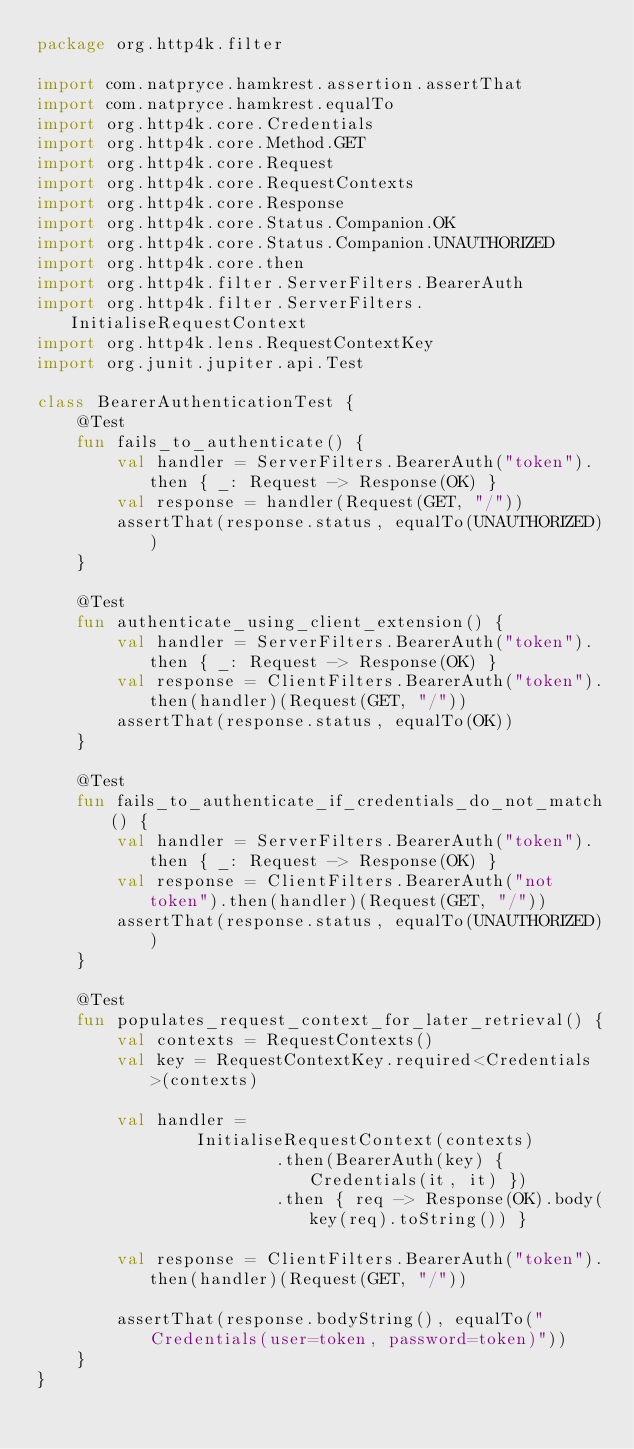Convert code to text. <code><loc_0><loc_0><loc_500><loc_500><_Kotlin_>package org.http4k.filter

import com.natpryce.hamkrest.assertion.assertThat
import com.natpryce.hamkrest.equalTo
import org.http4k.core.Credentials
import org.http4k.core.Method.GET
import org.http4k.core.Request
import org.http4k.core.RequestContexts
import org.http4k.core.Response
import org.http4k.core.Status.Companion.OK
import org.http4k.core.Status.Companion.UNAUTHORIZED
import org.http4k.core.then
import org.http4k.filter.ServerFilters.BearerAuth
import org.http4k.filter.ServerFilters.InitialiseRequestContext
import org.http4k.lens.RequestContextKey
import org.junit.jupiter.api.Test

class BearerAuthenticationTest {
    @Test
    fun fails_to_authenticate() {
        val handler = ServerFilters.BearerAuth("token").then { _: Request -> Response(OK) }
        val response = handler(Request(GET, "/"))
        assertThat(response.status, equalTo(UNAUTHORIZED))
    }

    @Test
    fun authenticate_using_client_extension() {
        val handler = ServerFilters.BearerAuth("token").then { _: Request -> Response(OK) }
        val response = ClientFilters.BearerAuth("token").then(handler)(Request(GET, "/"))
        assertThat(response.status, equalTo(OK))
    }

    @Test
    fun fails_to_authenticate_if_credentials_do_not_match() {
        val handler = ServerFilters.BearerAuth("token").then { _: Request -> Response(OK) }
        val response = ClientFilters.BearerAuth("not token").then(handler)(Request(GET, "/"))
        assertThat(response.status, equalTo(UNAUTHORIZED))
    }

    @Test
    fun populates_request_context_for_later_retrieval() {
        val contexts = RequestContexts()
        val key = RequestContextKey.required<Credentials>(contexts)

        val handler =
                InitialiseRequestContext(contexts)
                        .then(BearerAuth(key) { Credentials(it, it) })
                        .then { req -> Response(OK).body(key(req).toString()) }

        val response = ClientFilters.BearerAuth("token").then(handler)(Request(GET, "/"))

        assertThat(response.bodyString(), equalTo("Credentials(user=token, password=token)"))
    }
}
</code> 